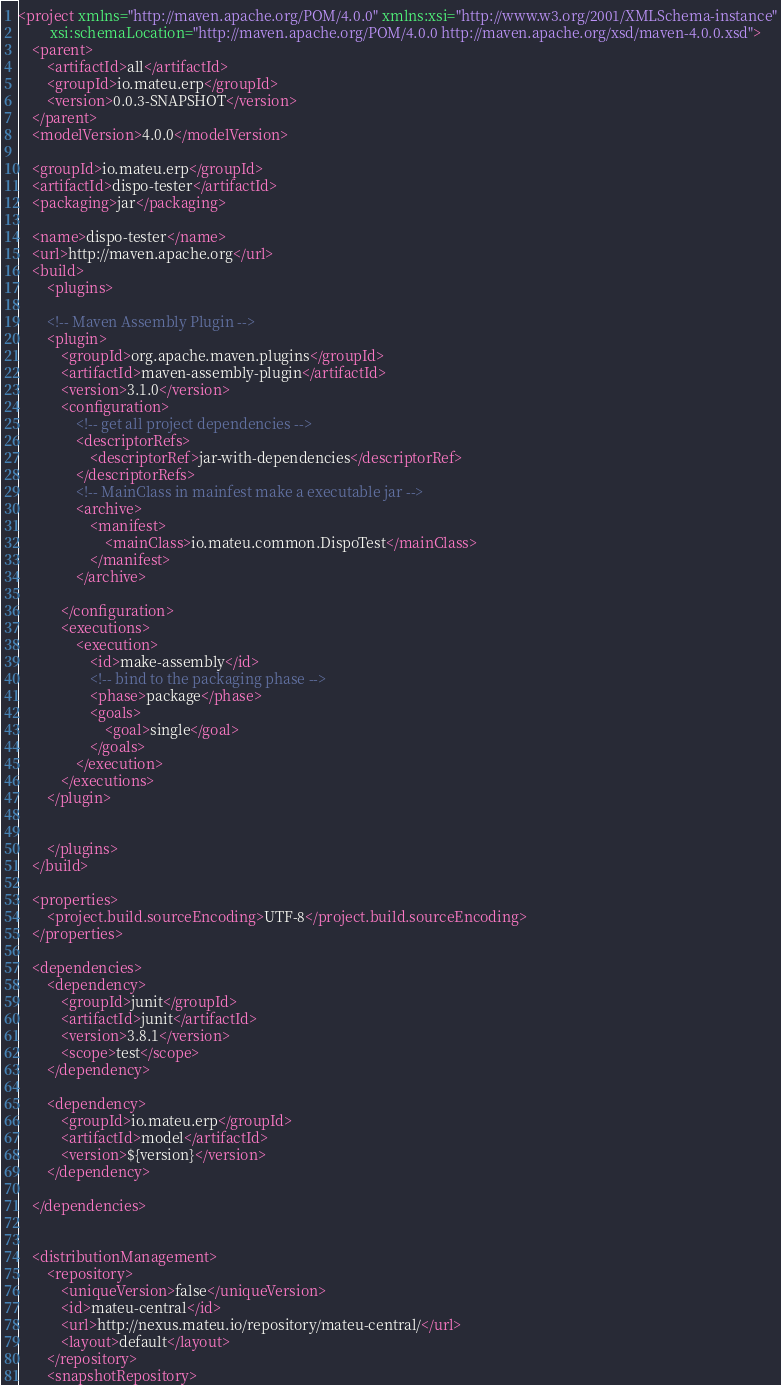<code> <loc_0><loc_0><loc_500><loc_500><_XML_><project xmlns="http://maven.apache.org/POM/4.0.0" xmlns:xsi="http://www.w3.org/2001/XMLSchema-instance"
         xsi:schemaLocation="http://maven.apache.org/POM/4.0.0 http://maven.apache.org/xsd/maven-4.0.0.xsd">
    <parent>
        <artifactId>all</artifactId>
        <groupId>io.mateu.erp</groupId>
        <version>0.0.3-SNAPSHOT</version>
    </parent>
    <modelVersion>4.0.0</modelVersion>

    <groupId>io.mateu.erp</groupId>
    <artifactId>dispo-tester</artifactId>
    <packaging>jar</packaging>

    <name>dispo-tester</name>
    <url>http://maven.apache.org</url>
    <build>
        <plugins>

        <!-- Maven Assembly Plugin -->
        <plugin>
            <groupId>org.apache.maven.plugins</groupId>
            <artifactId>maven-assembly-plugin</artifactId>
            <version>3.1.0</version>
            <configuration>
                <!-- get all project dependencies -->
                <descriptorRefs>
                    <descriptorRef>jar-with-dependencies</descriptorRef>
                </descriptorRefs>
                <!-- MainClass in mainfest make a executable jar -->
                <archive>
                    <manifest>
                        <mainClass>io.mateu.common.DispoTest</mainClass>
                    </manifest>
                </archive>

            </configuration>
            <executions>
                <execution>
                    <id>make-assembly</id>
                    <!-- bind to the packaging phase -->
                    <phase>package</phase>
                    <goals>
                        <goal>single</goal>
                    </goals>
                </execution>
            </executions>
        </plugin>


        </plugins>
    </build>

    <properties>
        <project.build.sourceEncoding>UTF-8</project.build.sourceEncoding>
    </properties>

    <dependencies>
        <dependency>
            <groupId>junit</groupId>
            <artifactId>junit</artifactId>
            <version>3.8.1</version>
            <scope>test</scope>
        </dependency>

        <dependency>
            <groupId>io.mateu.erp</groupId>
            <artifactId>model</artifactId>
            <version>${version}</version>
        </dependency>

    </dependencies>


    <distributionManagement>
        <repository>
            <uniqueVersion>false</uniqueVersion>
            <id>mateu-central</id>
            <url>http://nexus.mateu.io/repository/mateu-central/</url>
            <layout>default</layout>
        </repository>
        <snapshotRepository></code> 